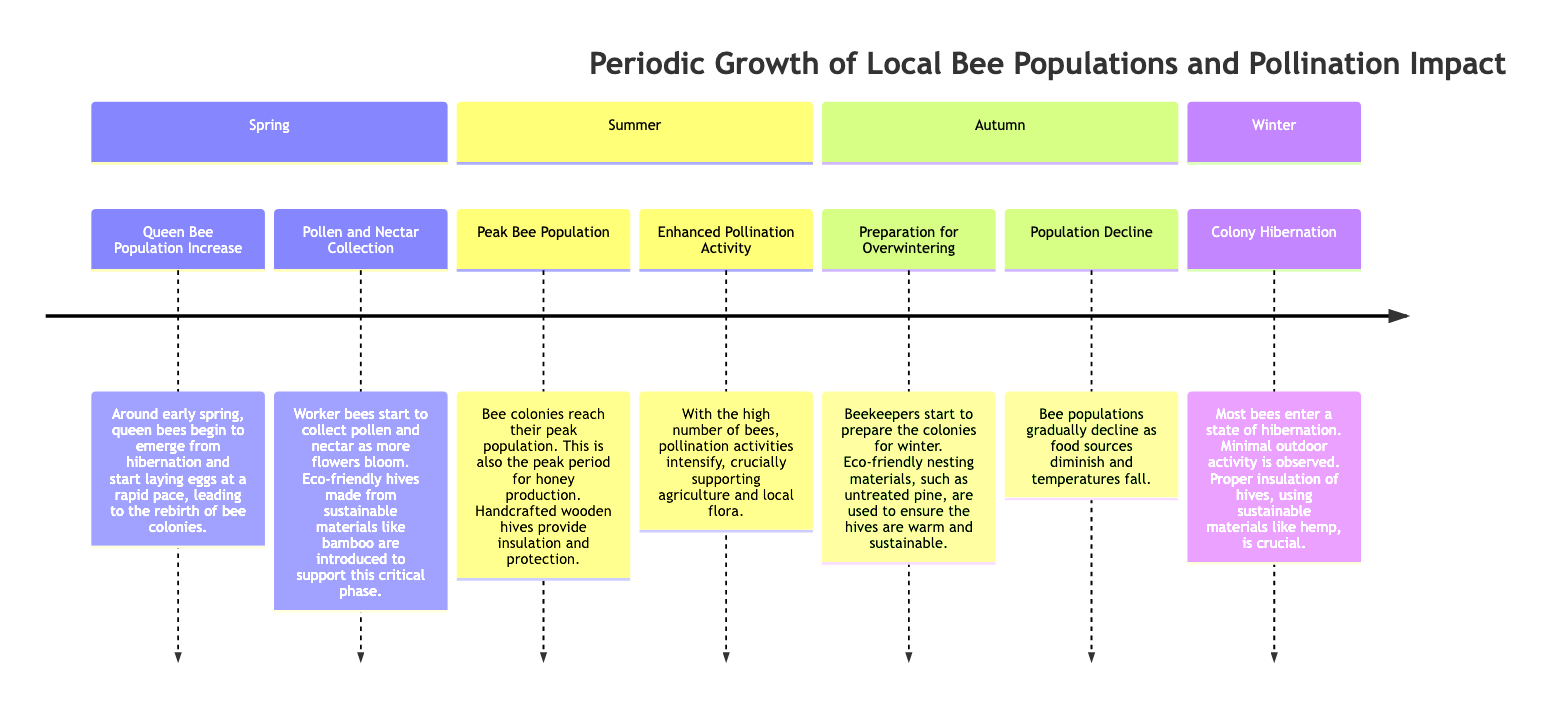What events occur in the Spring season? The diagram lists two events for Spring: "Queen Bee Population Increase" and "Pollen and Nectar Collection."
Answer: Queen Bee Population Increase, Pollen and Nectar Collection How does the bee population change in Autumn? According to the timeline, Autumn shows a "Population Decline" event, indicating that the bee populations gradually decrease.
Answer: Population Decline What eco-friendly material is suggested for hive insulation in Winter? The timeline specifies "hemp" as an important eco-friendly material for proper hive insulation during the Winter season.
Answer: Hemp Which season has the peak bee population? The diagram reveals that the "Summer" season is characterized by the "Peak Bee Population" event, marking the time when colonies reach their maximum numbers.
Answer: Summer What important activity intensifies during Summer? The "Enhanced Pollination Activity" event in the Summer season indicates that pollination activities greatly increase during this time.
Answer: Enhanced Pollination Activity How do bees prepare for Winter? The timeline describes the "Preparation for Overwintering" as a key event where beekeepers start to get the colonies ready for winter.
Answer: Preparation for Overwintering Which season follows after Spring in the timeline? The timeline's sequence shows "Summer" directly following "Spring."
Answer: Summer What occurs to bees after they enter hibernation? The diagram explains that during Winter, most bees enter a "Colony Hibernation," indicating a state of minimal activity.
Answer: Colony Hibernation 